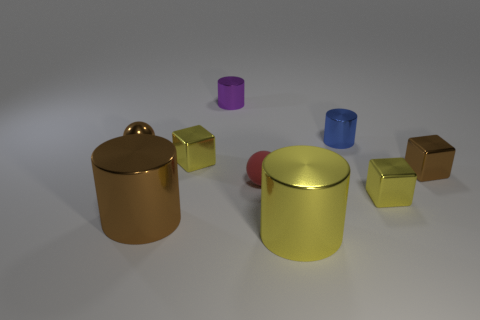Which objects in the picture seem to be the main focus, and why might that be? The main focus appears to be the larger yellow and bronze containers, due to their size, central positioning, and the fact that they stand out with their bright, reflective surfaces. They are likely intended to draw the viewer's eye more than the smaller objects, emphasizing their importance or aesthetic role in the composition. 